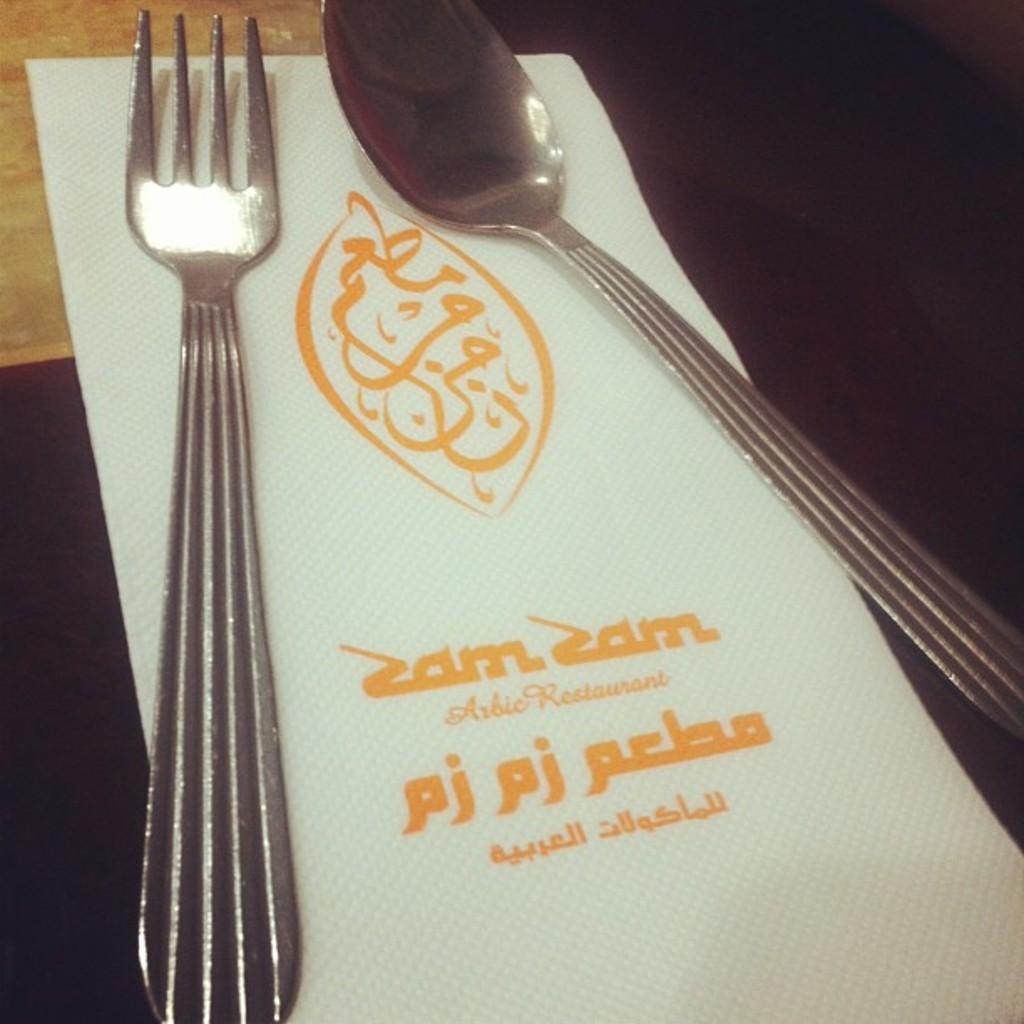What utensils can be seen in the image? There is a spoon and a fork in the image. Where are the spoon and fork placed in the image? The spoon and fork are on tissue paper. What type of quartz is being used as a reward for the ball in the image? There is no quartz, reward, or ball present in the image. 